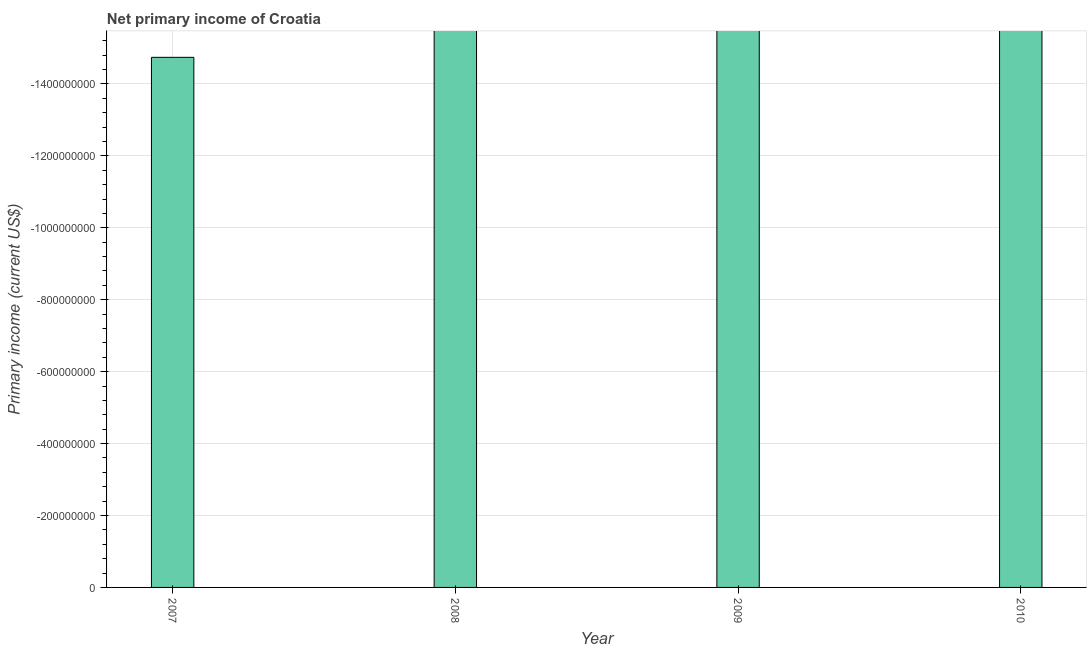Does the graph contain any zero values?
Your answer should be compact. Yes. What is the title of the graph?
Give a very brief answer. Net primary income of Croatia. What is the label or title of the Y-axis?
Your response must be concise. Primary income (current US$). What is the amount of primary income in 2007?
Ensure brevity in your answer.  0. What is the median amount of primary income?
Give a very brief answer. 0. In how many years, is the amount of primary income greater than -400000000 US$?
Your response must be concise. 0. How many bars are there?
Keep it short and to the point. 0. Are the values on the major ticks of Y-axis written in scientific E-notation?
Your response must be concise. No. What is the Primary income (current US$) in 2007?
Make the answer very short. 0. What is the Primary income (current US$) of 2010?
Your answer should be very brief. 0. 